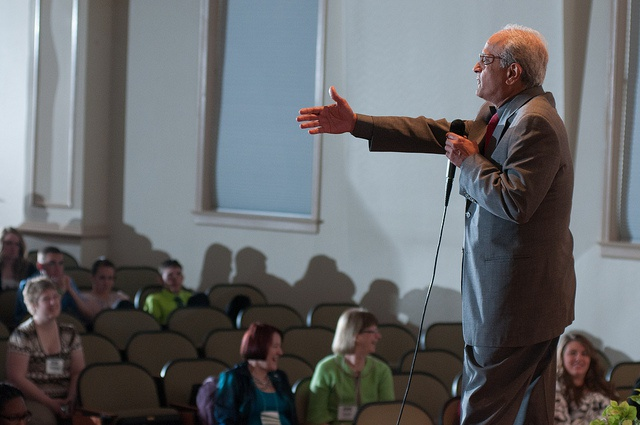Describe the objects in this image and their specific colors. I can see people in lightgray, black, gray, maroon, and darkgray tones, chair in lightgray, black, and gray tones, people in lightgray, black, gray, maroon, and darkgray tones, people in lightgray, black, darkgreen, and gray tones, and people in lightgray, black, maroon, gray, and darkblue tones in this image. 